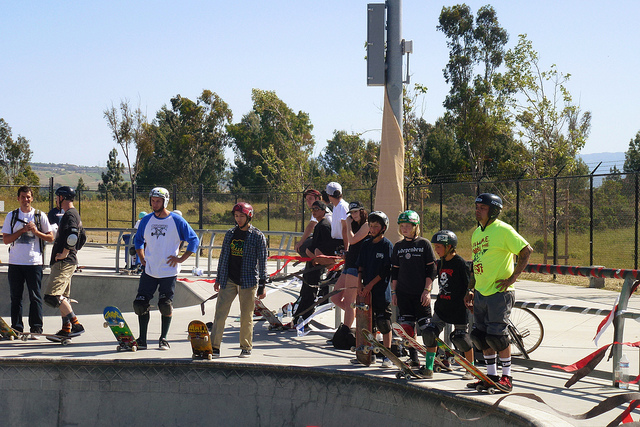<image>Are the boys happy? I don't know if the boys are happy. The expressions of happiness can vary and are subjective. Are the boys happy? I don't know if the boys are happy. It is possible that some of them are happy, but I cannot say for sure. 